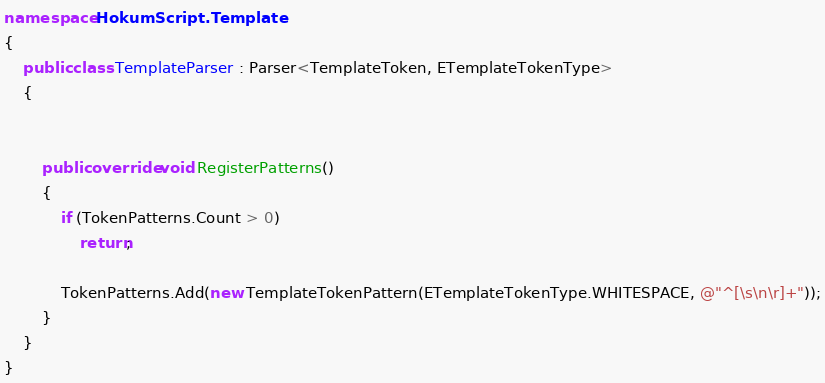<code> <loc_0><loc_0><loc_500><loc_500><_C#_>namespace HokumScript.Template
{
    public class TemplateParser : Parser<TemplateToken, ETemplateTokenType>
    {
        

        public override void RegisterPatterns()
        {
            if (TokenPatterns.Count > 0)
                return;

            TokenPatterns.Add(new TemplateTokenPattern(ETemplateTokenType.WHITESPACE, @"^[\s\n\r]+"));
        }
    }
}
</code> 